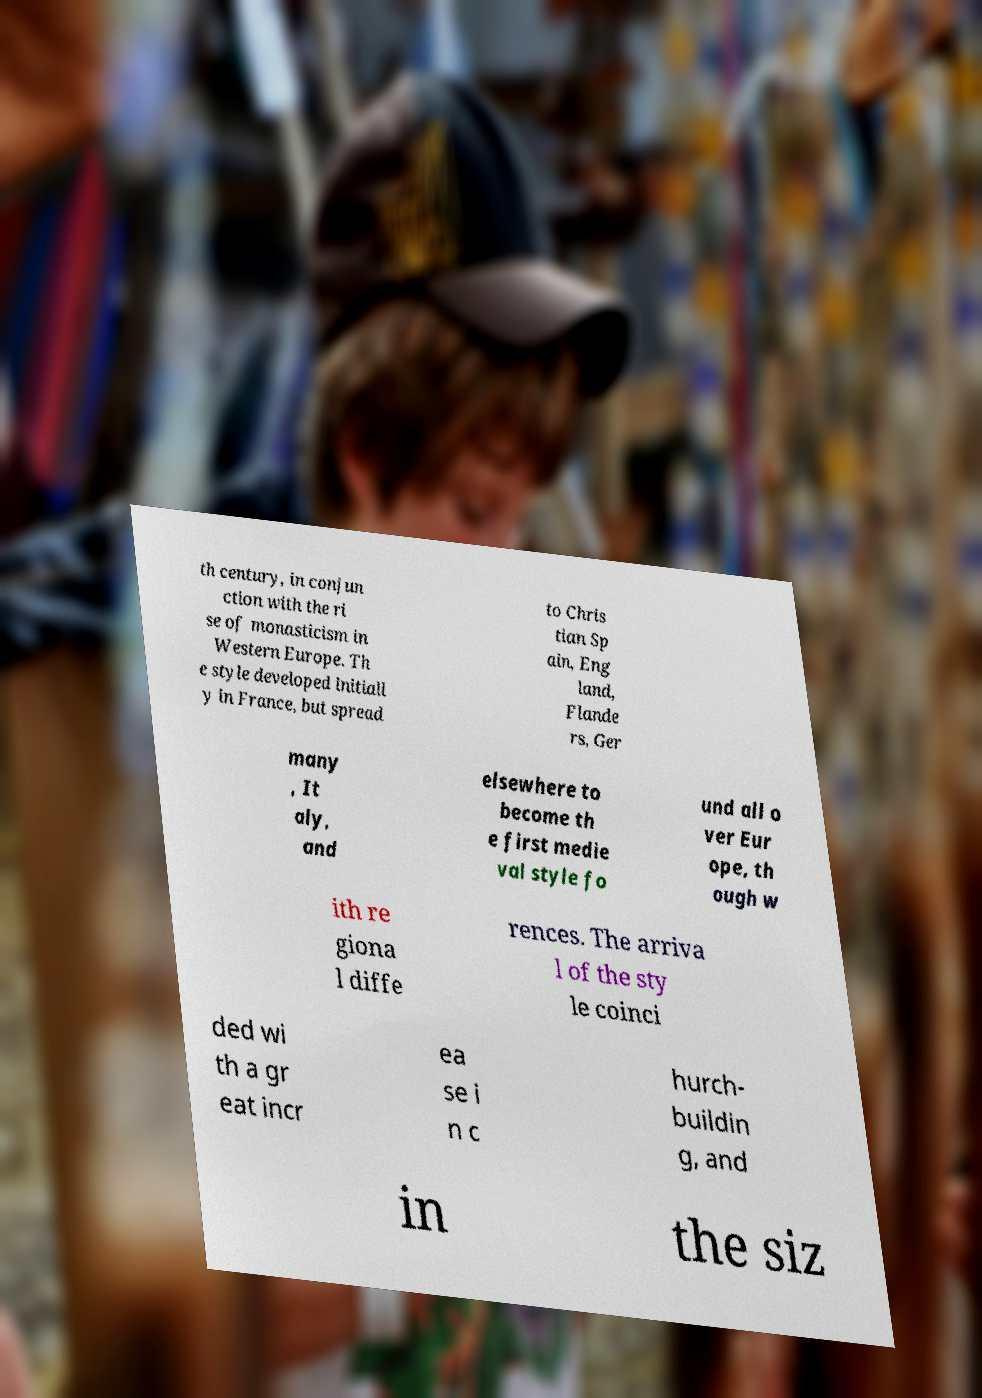Please read and relay the text visible in this image. What does it say? th century, in conjun ction with the ri se of monasticism in Western Europe. Th e style developed initiall y in France, but spread to Chris tian Sp ain, Eng land, Flande rs, Ger many , It aly, and elsewhere to become th e first medie val style fo und all o ver Eur ope, th ough w ith re giona l diffe rences. The arriva l of the sty le coinci ded wi th a gr eat incr ea se i n c hurch- buildin g, and in the siz 